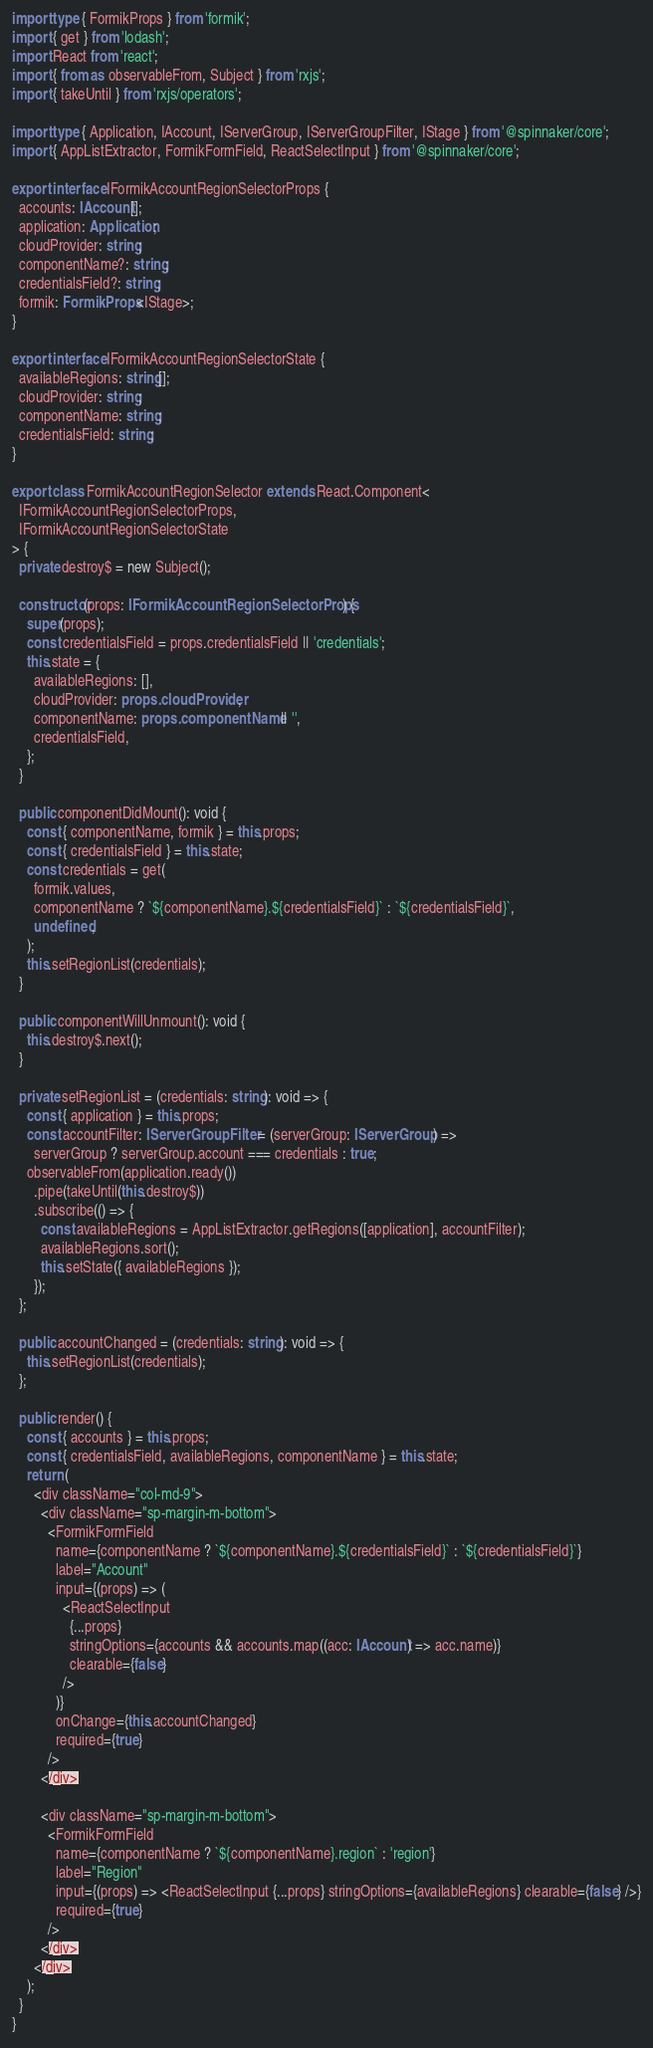<code> <loc_0><loc_0><loc_500><loc_500><_TypeScript_>import type { FormikProps } from 'formik';
import { get } from 'lodash';
import React from 'react';
import { from as observableFrom, Subject } from 'rxjs';
import { takeUntil } from 'rxjs/operators';

import type { Application, IAccount, IServerGroup, IServerGroupFilter, IStage } from '@spinnaker/core';
import { AppListExtractor, FormikFormField, ReactSelectInput } from '@spinnaker/core';

export interface IFormikAccountRegionSelectorProps {
  accounts: IAccount[];
  application: Application;
  cloudProvider: string;
  componentName?: string;
  credentialsField?: string;
  formik: FormikProps<IStage>;
}

export interface IFormikAccountRegionSelectorState {
  availableRegions: string[];
  cloudProvider: string;
  componentName: string;
  credentialsField: string;
}

export class FormikAccountRegionSelector extends React.Component<
  IFormikAccountRegionSelectorProps,
  IFormikAccountRegionSelectorState
> {
  private destroy$ = new Subject();

  constructor(props: IFormikAccountRegionSelectorProps) {
    super(props);
    const credentialsField = props.credentialsField || 'credentials';
    this.state = {
      availableRegions: [],
      cloudProvider: props.cloudProvider,
      componentName: props.componentName || '',
      credentialsField,
    };
  }

  public componentDidMount(): void {
    const { componentName, formik } = this.props;
    const { credentialsField } = this.state;
    const credentials = get(
      formik.values,
      componentName ? `${componentName}.${credentialsField}` : `${credentialsField}`,
      undefined,
    );
    this.setRegionList(credentials);
  }

  public componentWillUnmount(): void {
    this.destroy$.next();
  }

  private setRegionList = (credentials: string): void => {
    const { application } = this.props;
    const accountFilter: IServerGroupFilter = (serverGroup: IServerGroup) =>
      serverGroup ? serverGroup.account === credentials : true;
    observableFrom(application.ready())
      .pipe(takeUntil(this.destroy$))
      .subscribe(() => {
        const availableRegions = AppListExtractor.getRegions([application], accountFilter);
        availableRegions.sort();
        this.setState({ availableRegions });
      });
  };

  public accountChanged = (credentials: string): void => {
    this.setRegionList(credentials);
  };

  public render() {
    const { accounts } = this.props;
    const { credentialsField, availableRegions, componentName } = this.state;
    return (
      <div className="col-md-9">
        <div className="sp-margin-m-bottom">
          <FormikFormField
            name={componentName ? `${componentName}.${credentialsField}` : `${credentialsField}`}
            label="Account"
            input={(props) => (
              <ReactSelectInput
                {...props}
                stringOptions={accounts && accounts.map((acc: IAccount) => acc.name)}
                clearable={false}
              />
            )}
            onChange={this.accountChanged}
            required={true}
          />
        </div>

        <div className="sp-margin-m-bottom">
          <FormikFormField
            name={componentName ? `${componentName}.region` : 'region'}
            label="Region"
            input={(props) => <ReactSelectInput {...props} stringOptions={availableRegions} clearable={false} />}
            required={true}
          />
        </div>
      </div>
    );
  }
}
</code> 